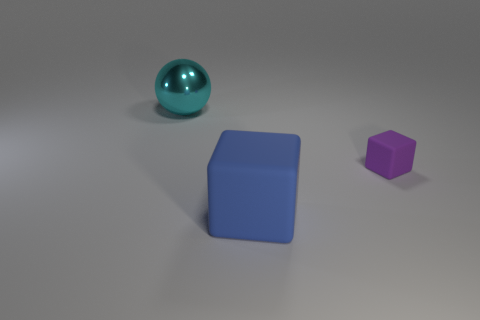What is the object that is in front of the large metallic object and to the left of the small purple rubber block made of?
Your response must be concise. Rubber. Is there any other thing that has the same shape as the tiny thing?
Provide a succinct answer. Yes. How many things are both on the left side of the tiny purple object and in front of the big cyan object?
Your answer should be compact. 1. Are there an equal number of big blue matte cubes and small blue matte cubes?
Your answer should be very brief. No. What material is the blue object?
Your answer should be very brief. Rubber. Are there an equal number of purple cubes to the left of the purple matte thing and large blocks?
Give a very brief answer. No. How many big cyan objects have the same shape as the small object?
Your answer should be compact. 0. Does the metallic thing have the same shape as the big blue rubber object?
Ensure brevity in your answer.  No. How many objects are large objects to the right of the big metallic ball or purple matte objects?
Your response must be concise. 2. The matte thing left of the rubber thing that is behind the big thing that is in front of the shiny ball is what shape?
Make the answer very short. Cube. 